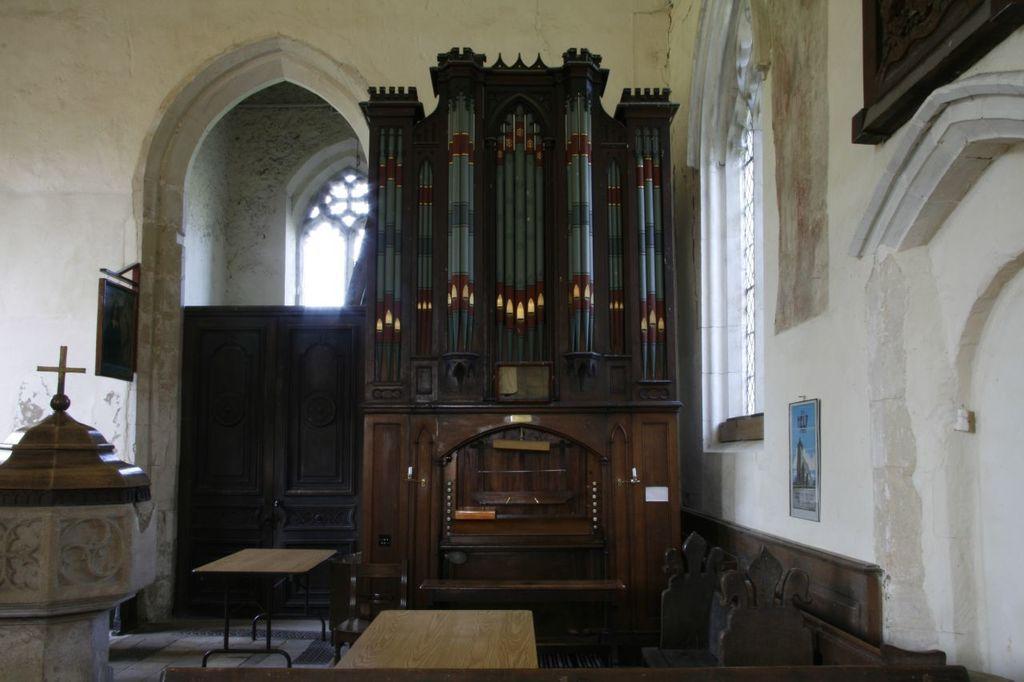In one or two sentences, can you explain what this image depicts? In this picture we can see two tables where, there is a Christianity symbol here, on the right side there is a wall, we can see a photo frame on the wall. 